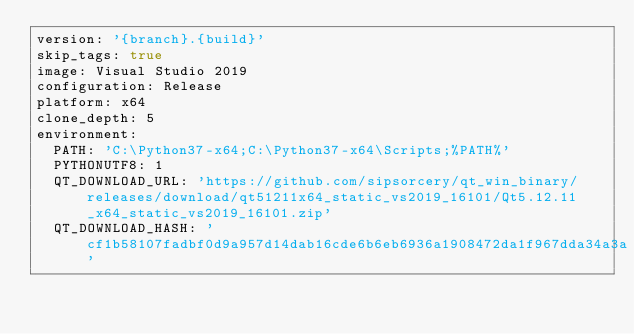<code> <loc_0><loc_0><loc_500><loc_500><_YAML_>version: '{branch}.{build}'
skip_tags: true
image: Visual Studio 2019
configuration: Release
platform: x64
clone_depth: 5
environment:
  PATH: 'C:\Python37-x64;C:\Python37-x64\Scripts;%PATH%'
  PYTHONUTF8: 1
  QT_DOWNLOAD_URL: 'https://github.com/sipsorcery/qt_win_binary/releases/download/qt51211x64_static_vs2019_16101/Qt5.12.11_x64_static_vs2019_16101.zip'
  QT_DOWNLOAD_HASH: 'cf1b58107fadbf0d9a957d14dab16cde6b6eb6936a1908472da1f967dda34a3a'</code> 